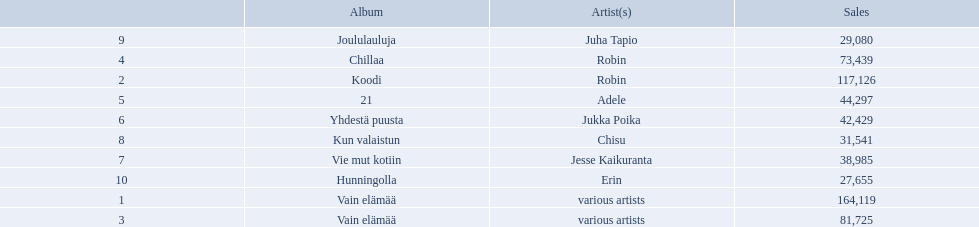Which albums had number-one albums in finland in 2012? 1, Vain elämää, Koodi, Vain elämää, Chillaa, 21, Yhdestä puusta, Vie mut kotiin, Kun valaistun, Joululauluja, Hunningolla. Of those albums, which were recorded by only one artist? Koodi, Chillaa, 21, Yhdestä puusta, Vie mut kotiin, Kun valaistun, Joululauluja, Hunningolla. Which albums made between 30,000 and 45,000 in sales? 21, Yhdestä puusta, Vie mut kotiin, Kun valaistun. Of those albums which had the highest sales? 21. Who was the artist for that album? Adele. 